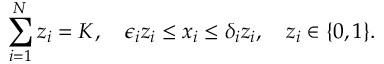<formula> <loc_0><loc_0><loc_500><loc_500>\sum _ { i = 1 } ^ { N } z _ { i } = K , \quad \epsilon _ { i } z _ { i } \leq x _ { i } \leq \delta _ { i } z _ { i } , \quad z _ { i } \in \{ 0 , 1 \} .</formula> 